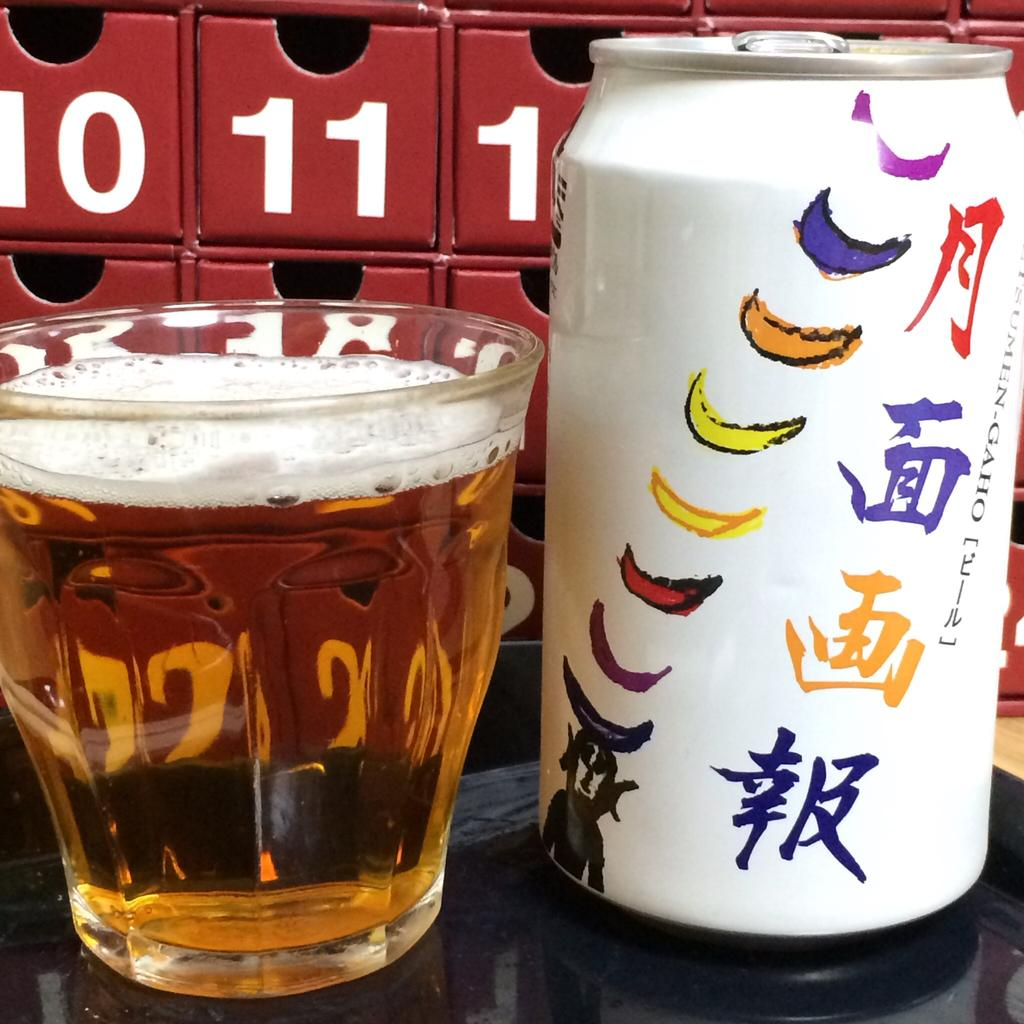Provide a one-sentence caption for the provided image. A can of Japanese beer sitting in front of boxes labeled with the numbers 10, 11, 12. 